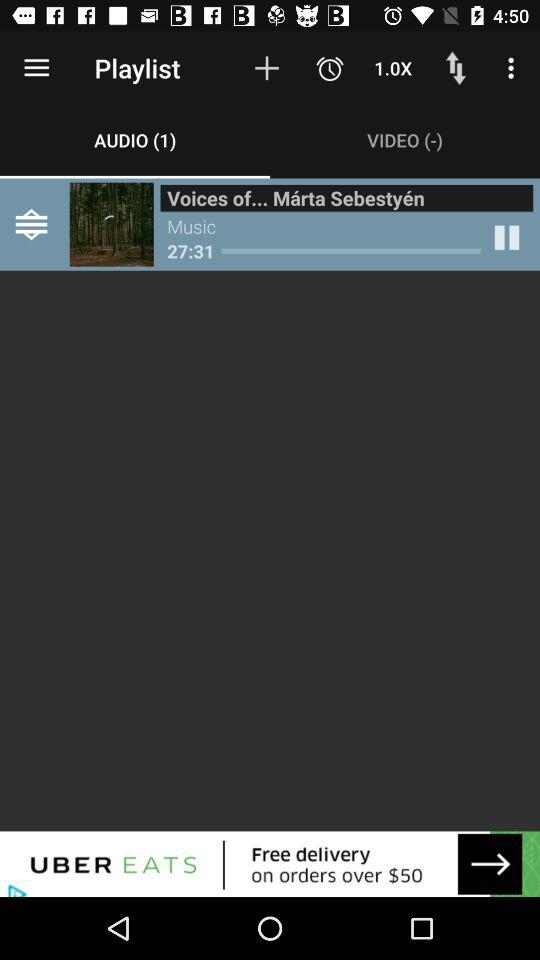How many episodes are there in "Falling Tree Productions"? There are 96 episodes in "Falling Tree Productions". 